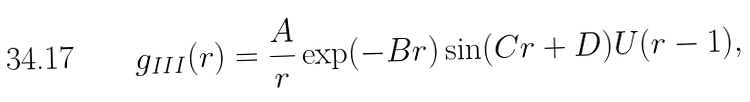<formula> <loc_0><loc_0><loc_500><loc_500>g _ { I I I } ( r ) = \frac { A } { r } \exp ( - B r ) \sin ( C r + D ) U ( r - 1 ) ,</formula> 